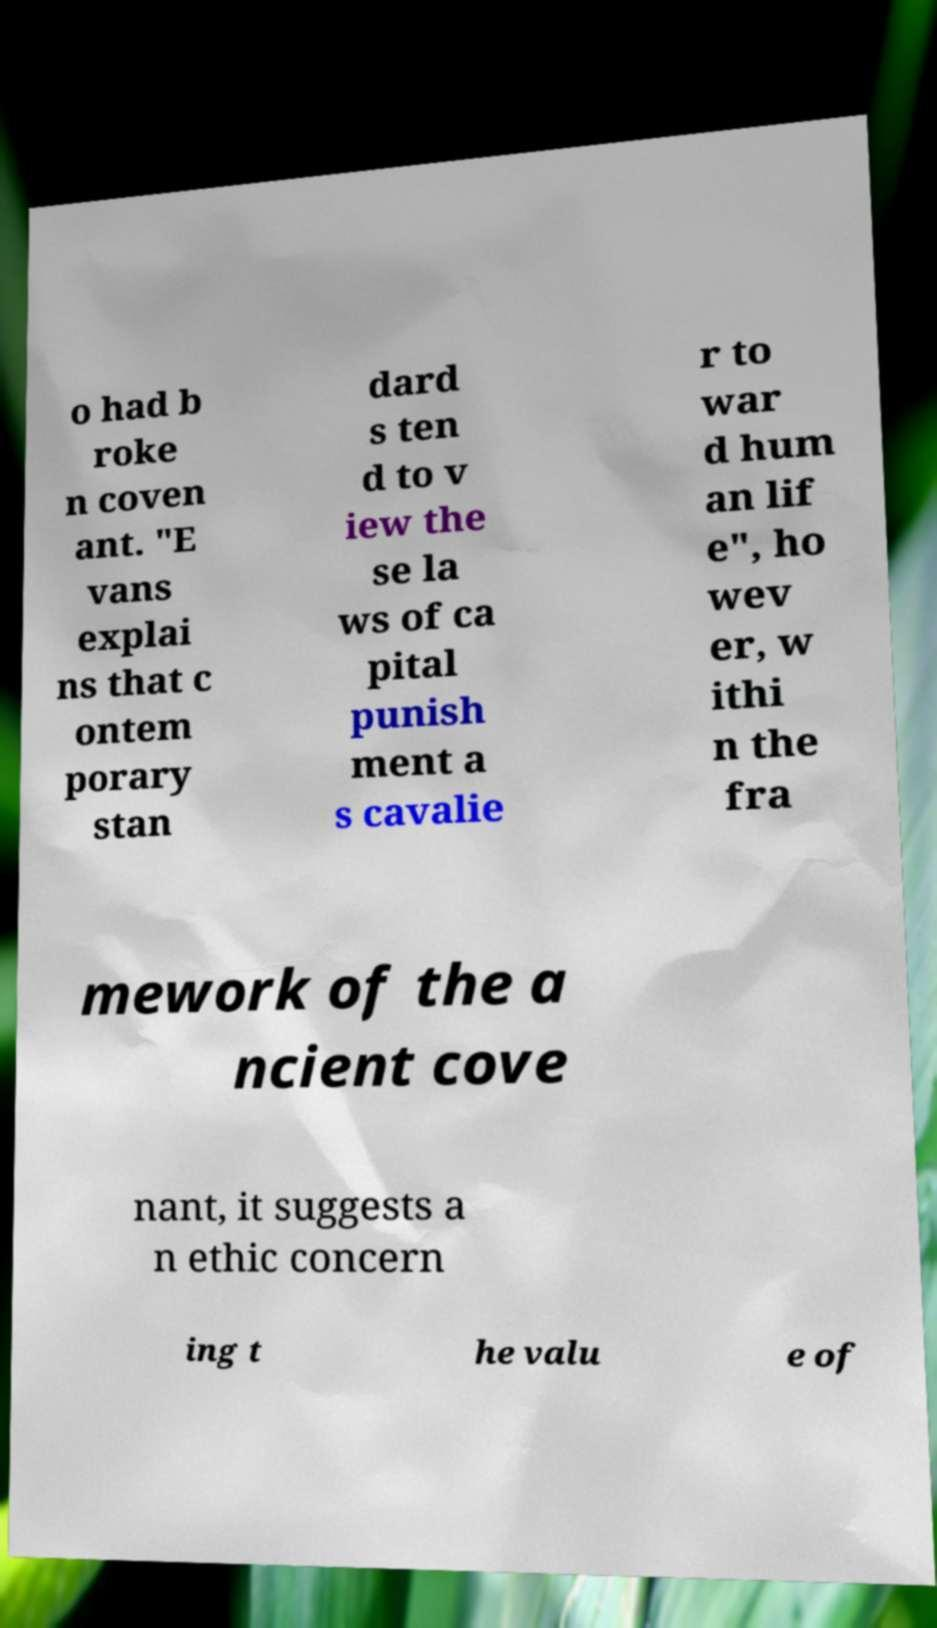Could you assist in decoding the text presented in this image and type it out clearly? o had b roke n coven ant. "E vans explai ns that c ontem porary stan dard s ten d to v iew the se la ws of ca pital punish ment a s cavalie r to war d hum an lif e", ho wev er, w ithi n the fra mework of the a ncient cove nant, it suggests a n ethic concern ing t he valu e of 